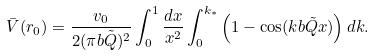<formula> <loc_0><loc_0><loc_500><loc_500>\bar { V } ( { r } _ { 0 } ) = \frac { v _ { 0 } } { 2 ( \pi b \tilde { Q } ) ^ { 2 } } \int _ { 0 } ^ { 1 } \frac { d x } { x ^ { 2 } } \int _ { 0 } ^ { k _ { \ast } } \left ( 1 - \cos ( k b \tilde { Q } x ) \right ) d k .</formula> 